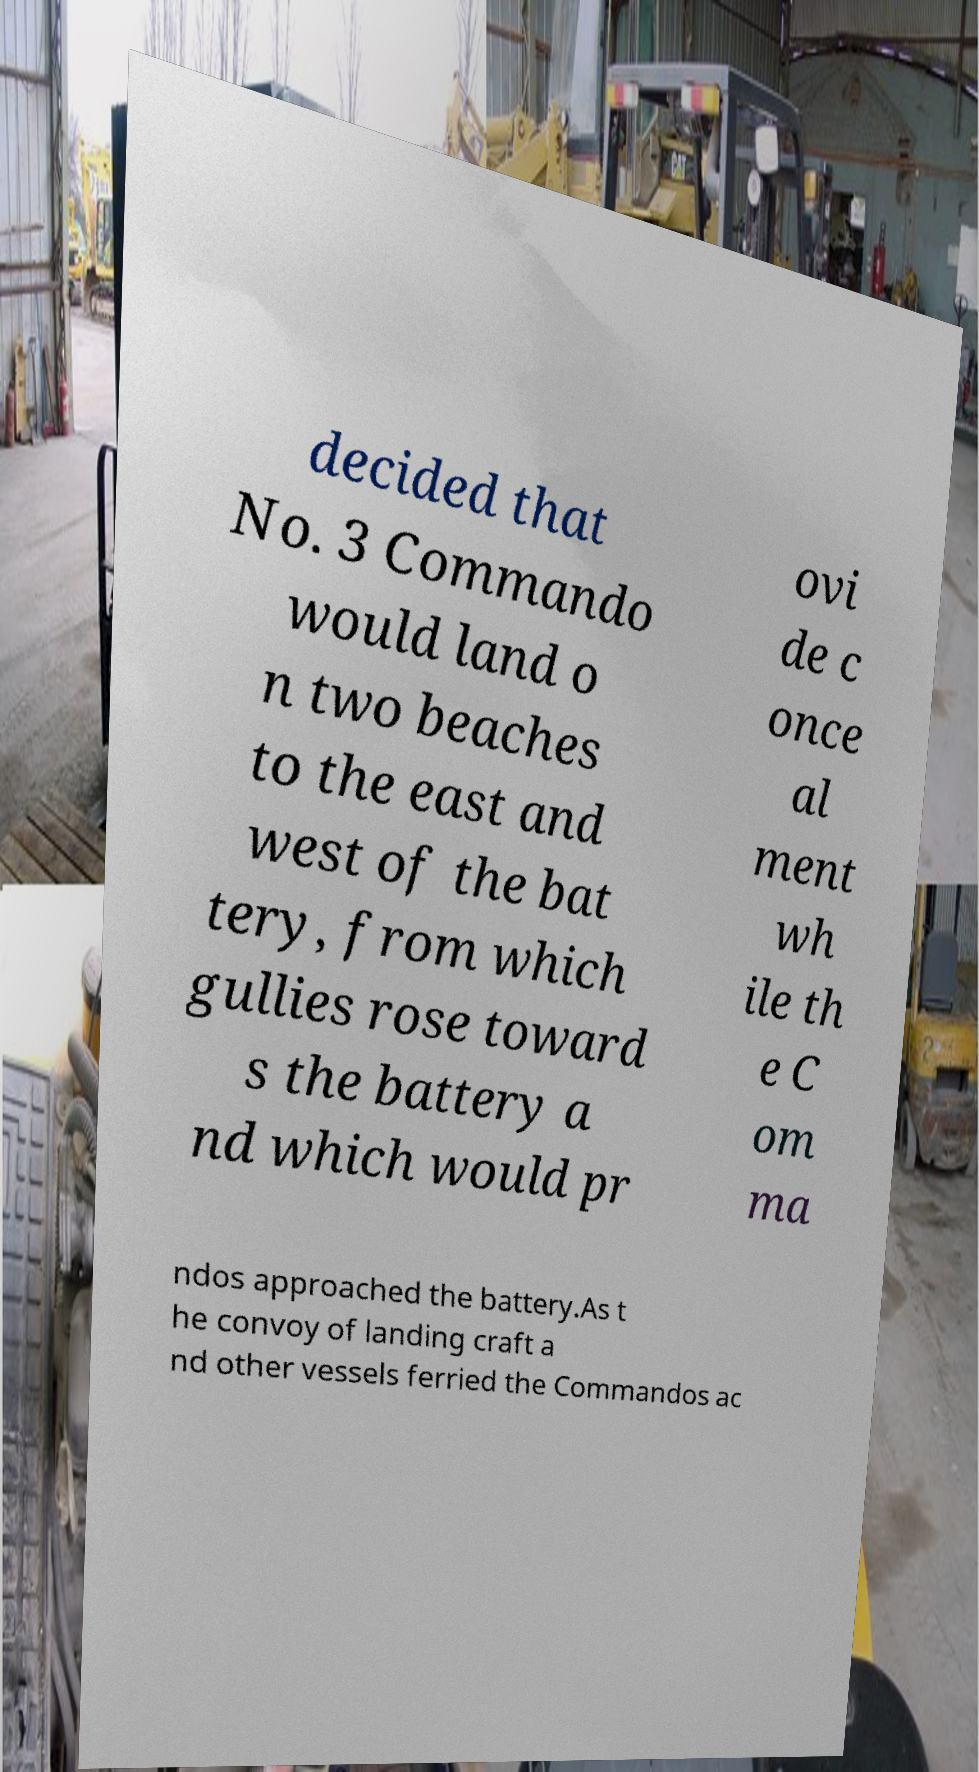Could you assist in decoding the text presented in this image and type it out clearly? decided that No. 3 Commando would land o n two beaches to the east and west of the bat tery, from which gullies rose toward s the battery a nd which would pr ovi de c once al ment wh ile th e C om ma ndos approached the battery.As t he convoy of landing craft a nd other vessels ferried the Commandos ac 